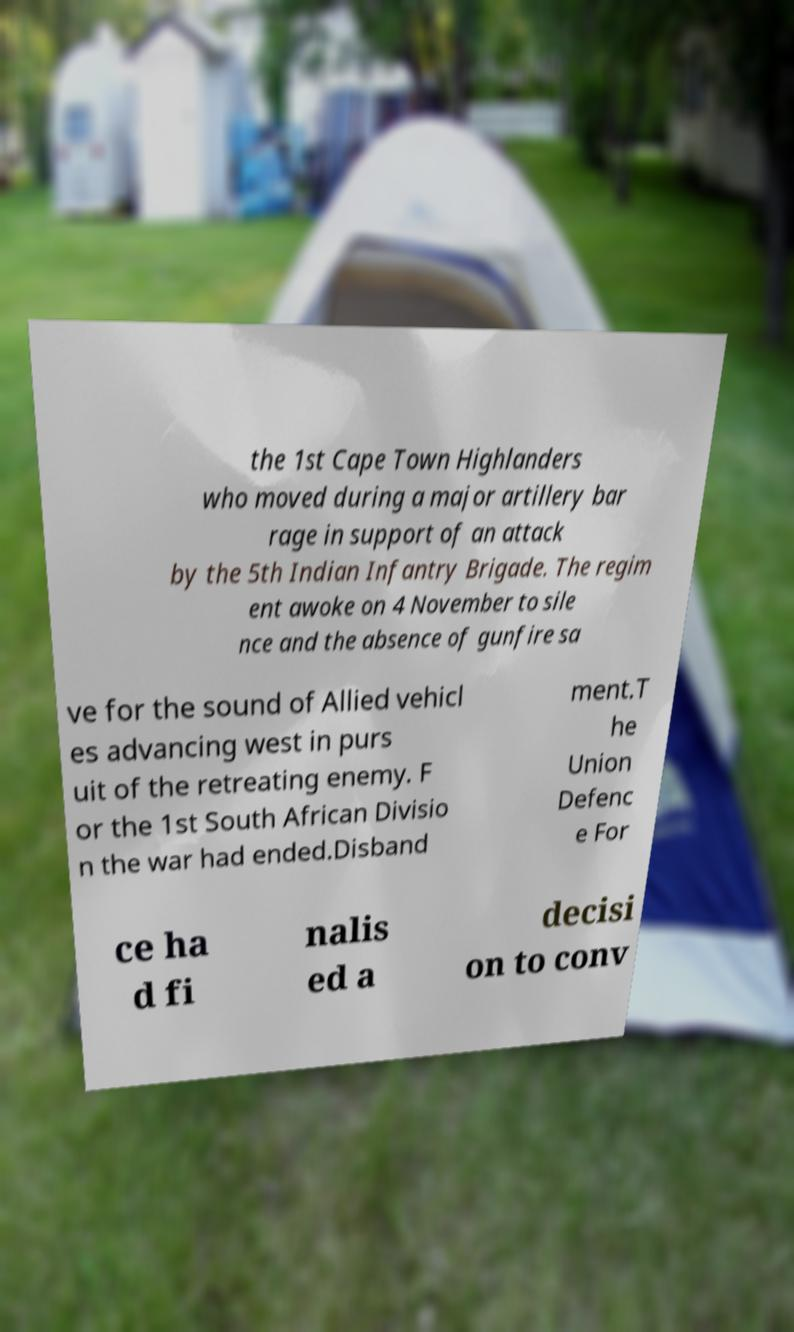There's text embedded in this image that I need extracted. Can you transcribe it verbatim? the 1st Cape Town Highlanders who moved during a major artillery bar rage in support of an attack by the 5th Indian Infantry Brigade. The regim ent awoke on 4 November to sile nce and the absence of gunfire sa ve for the sound of Allied vehicl es advancing west in purs uit of the retreating enemy. F or the 1st South African Divisio n the war had ended.Disband ment.T he Union Defenc e For ce ha d fi nalis ed a decisi on to conv 